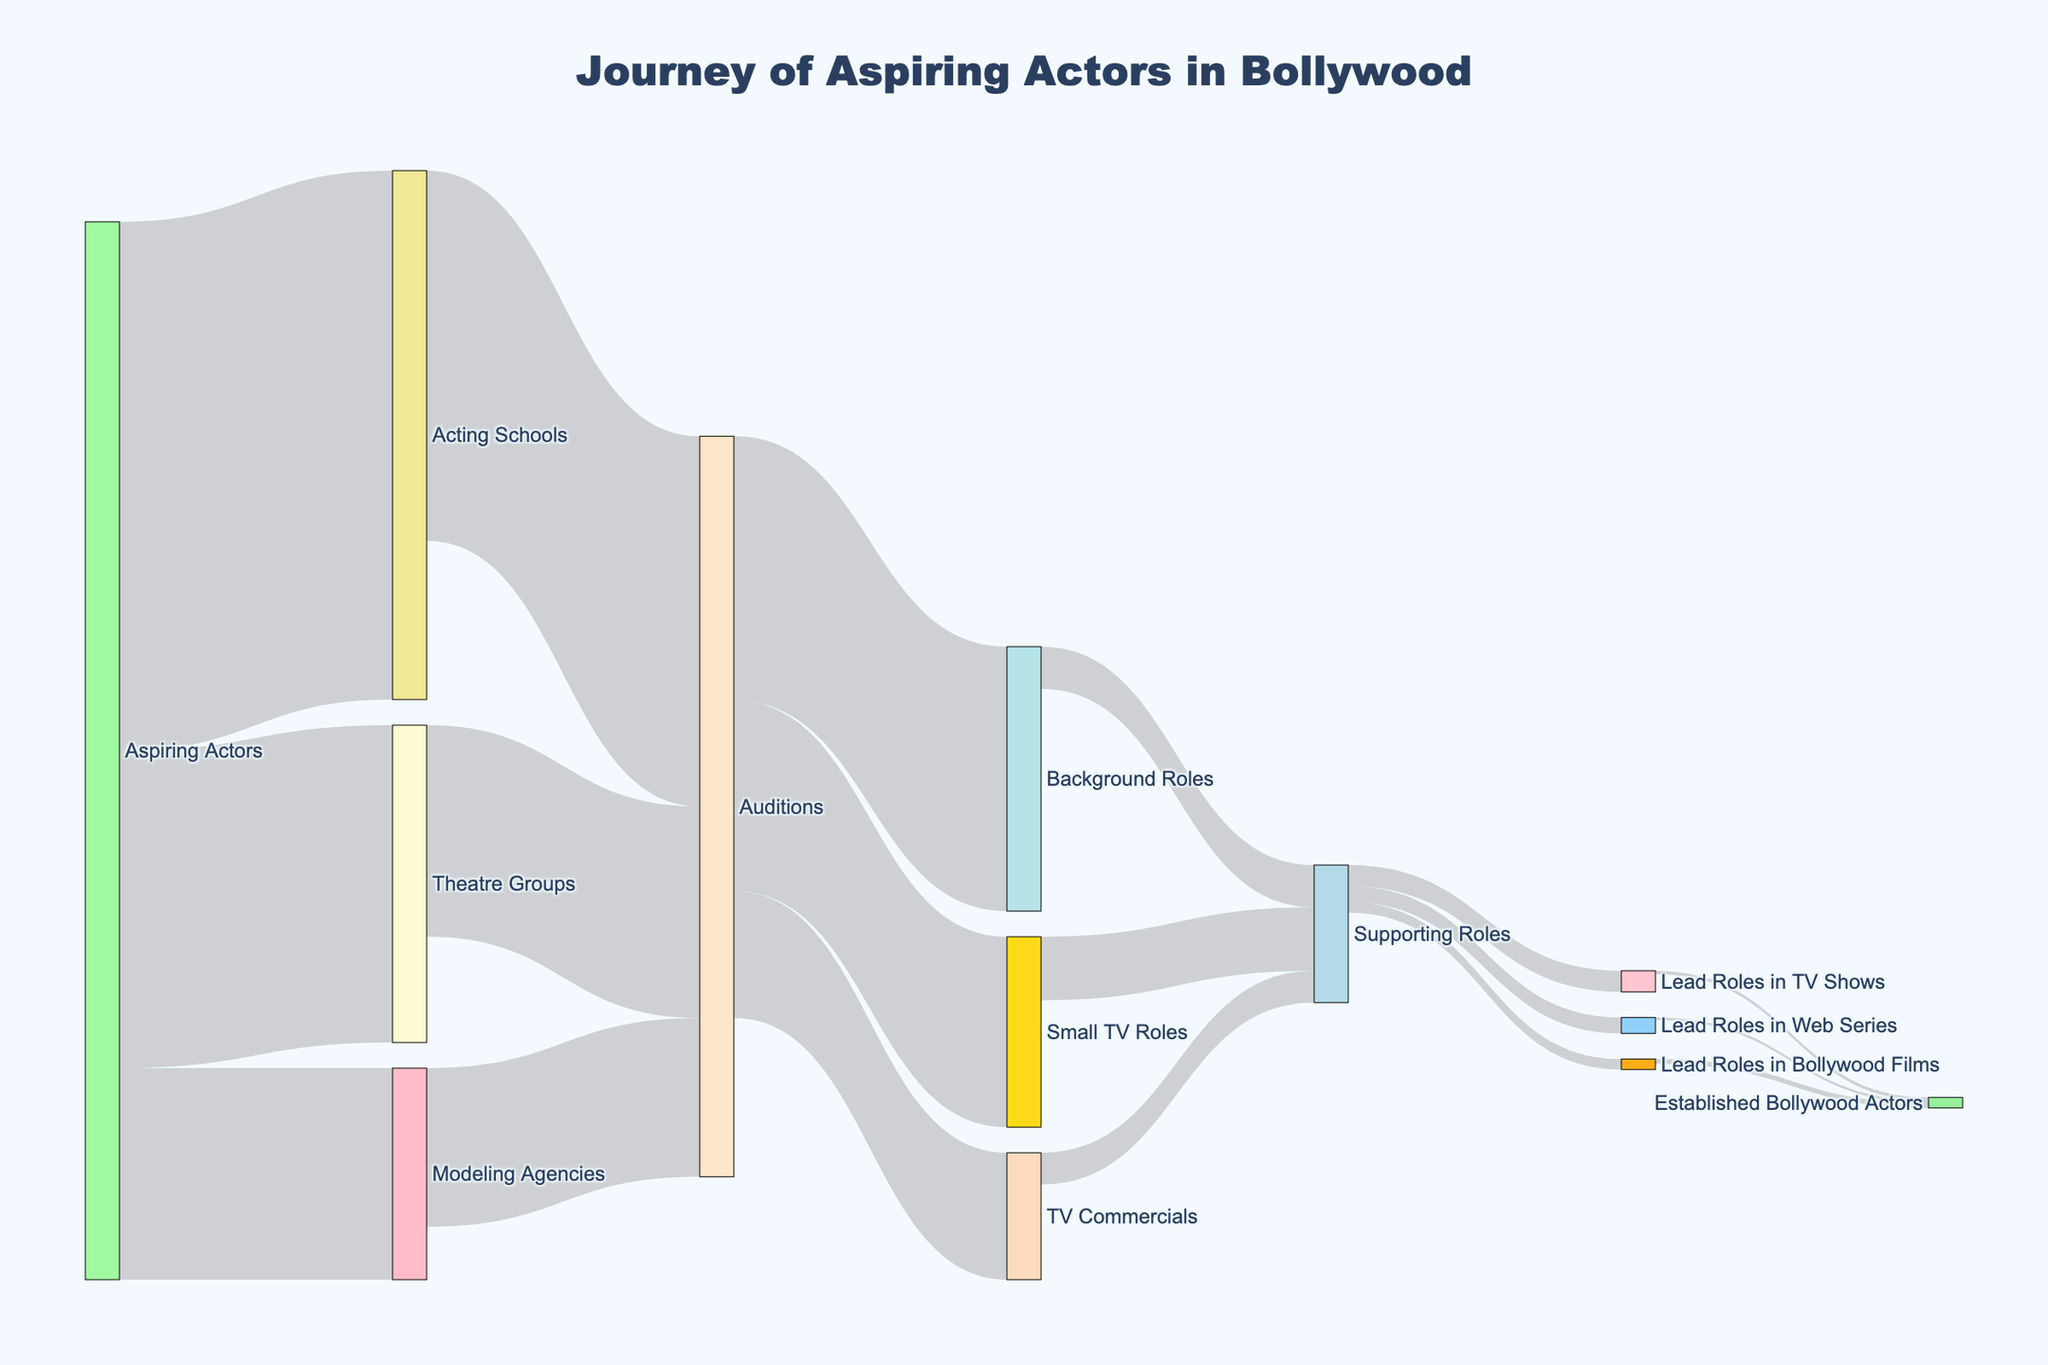What's the title of the figure? The title of the figure is displayed at the top and it reads "Journey of Aspiring Actors in Bollywood"
Answer: Journey of Aspiring Actors in Bollywood How many aspiring actors go through acting schools initially? By referring to the figure, the flow from "Aspiring Actors" to "Acting Schools" is represented with a value of 5000
Answer: 5000 What is the sum of aspiring actors going to auditions from all sources? Sum the values from Acting Schools to Auditions (3500), Theatre Groups to Auditions (2000), and Modeling Agencies to Auditions (1500): 3500 + 2000 + 1500 = 7000
Answer: 7000 Which path has the highest number of actors flowing initially after aspiring actors? The path from Aspiring Actors to Acting Schools has the highest value, which is 5000
Answer: Acting Schools What is the final number of established Bollywood actors? Add the values from Lead Roles in TV Shows (30), Lead Roles in Web Series (25), and Lead Roles in Bollywood Films (45): 30 + 25 + 45 = 100
Answer: 100 Do more actors end up in TV Commercials or Background Roles after auditions? Compare the values from Auditions to TV Commercials (1200) and Auditions to Background Roles (2500). The value for Background Roles is higher
Answer: Background Roles How many actors from supporting roles get lead roles in Bollywood Films? The value from Supporting Roles to Lead Roles in Bollywood Films is explicitly given as 100
Answer: 100 What percentage of aspiring actors start their journey in theatre groups? Divide the number going to Theatre Groups (3000) by the total aspiring actors (5000 + 3000 + 2000 = 10000) and multiply by 100: (3000 / 10000) * 100 = 30%
Answer: 30% How many actors get lead roles in TV shows after supporting roles? The value from Supporting Roles to Lead Roles in TV Shows is provided as 200
Answer: 200 Which transition has the smallest number of actors, and what is the value? By examining all the flows, the smallest number of actors is found in the transition from Lead Roles in Web Series to Established Bollywood Actors, with a value of 25
Answer: Lead Roles in Web Series to Established Bollywood Actors, 25 